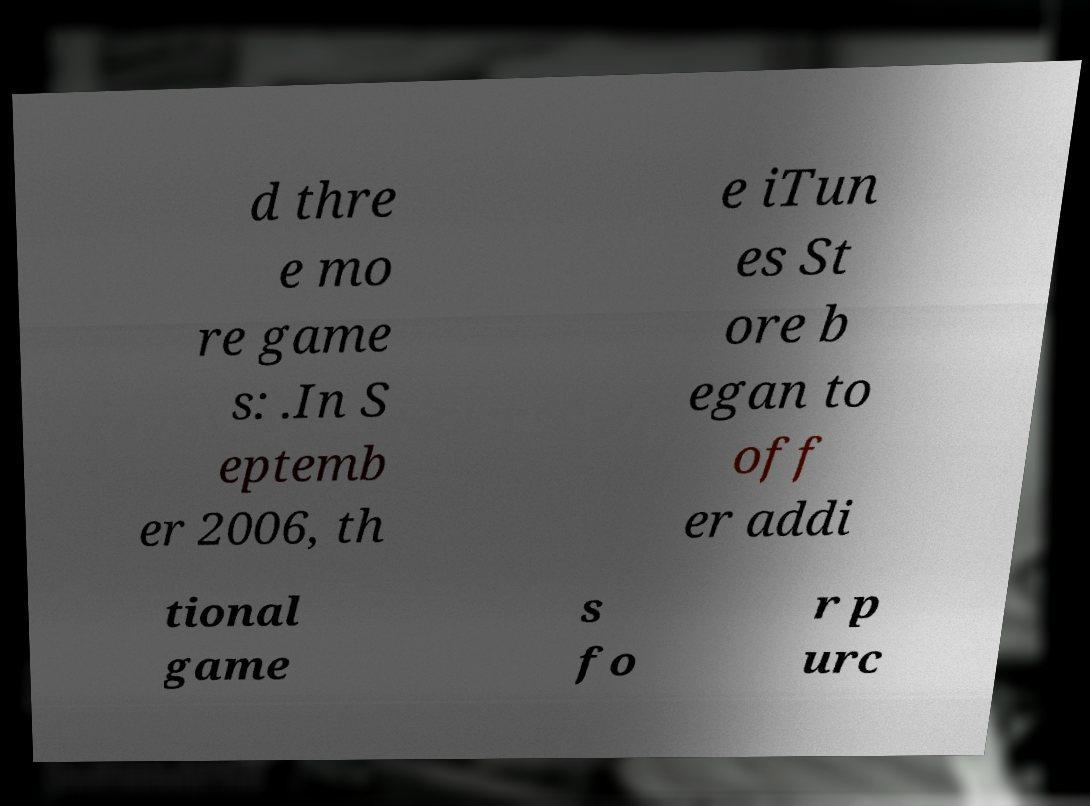Please identify and transcribe the text found in this image. d thre e mo re game s: .In S eptemb er 2006, th e iTun es St ore b egan to off er addi tional game s fo r p urc 